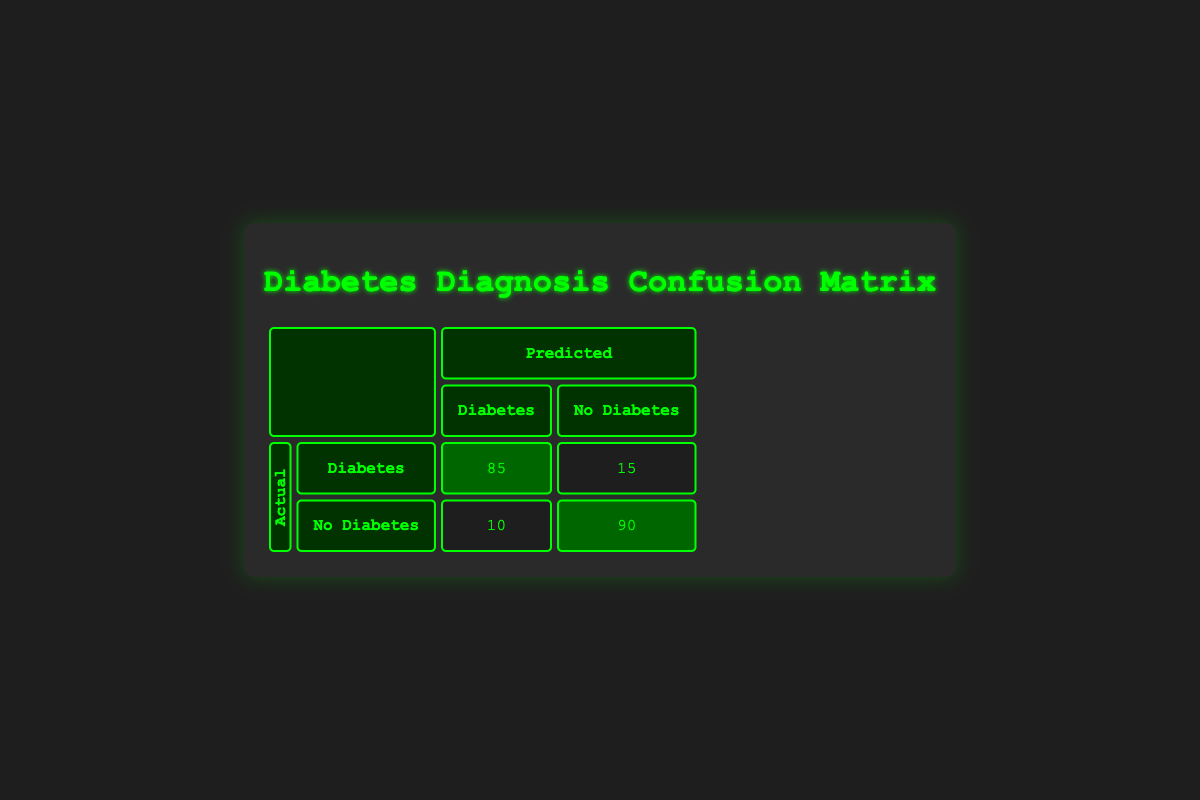What is the count of True Positives in the confusion matrix? True Positives are predicted as positive and are actually positive. In the table, this corresponds to the "Diabetes" row and "Diabetes" column, which has a count of 85.
Answer: 85 What is the count of False Negatives in the confusion matrix? False Negatives are predicted as negative but are actually positive. This is found in the "Diabetes" row and "No Diabetes" column, which has a count of 15.
Answer: 15 What is the total number of patients with No Diabetes in the dataset? The total for patients with No Diabetes is calculated by summing the counts in the "No Diabetes" row. This includes the counts of 10 (False Positives) and 90 (True Negatives), which totals to 10 + 90 = 100.
Answer: 100 Is the number of True Negatives greater than the number of False Positives? True Negatives are in the "No Diabetes" row and "No Diabetes" column (90) and False Positives are in the "No Diabetes" row and "Diabetes" column (10). Since 90 is greater than 10, the statement is true.
Answer: Yes What is the overall accuracy of the model? To calculate accuracy, you need to sum all True Positives and True Negatives (85 + 90 = 175) and divide by the total number of predictions (85 + 15 + 10 + 90 = 200). Thus, accuracy = 175 / 200 = 0.875 or 87.5%.
Answer: 87.5% 